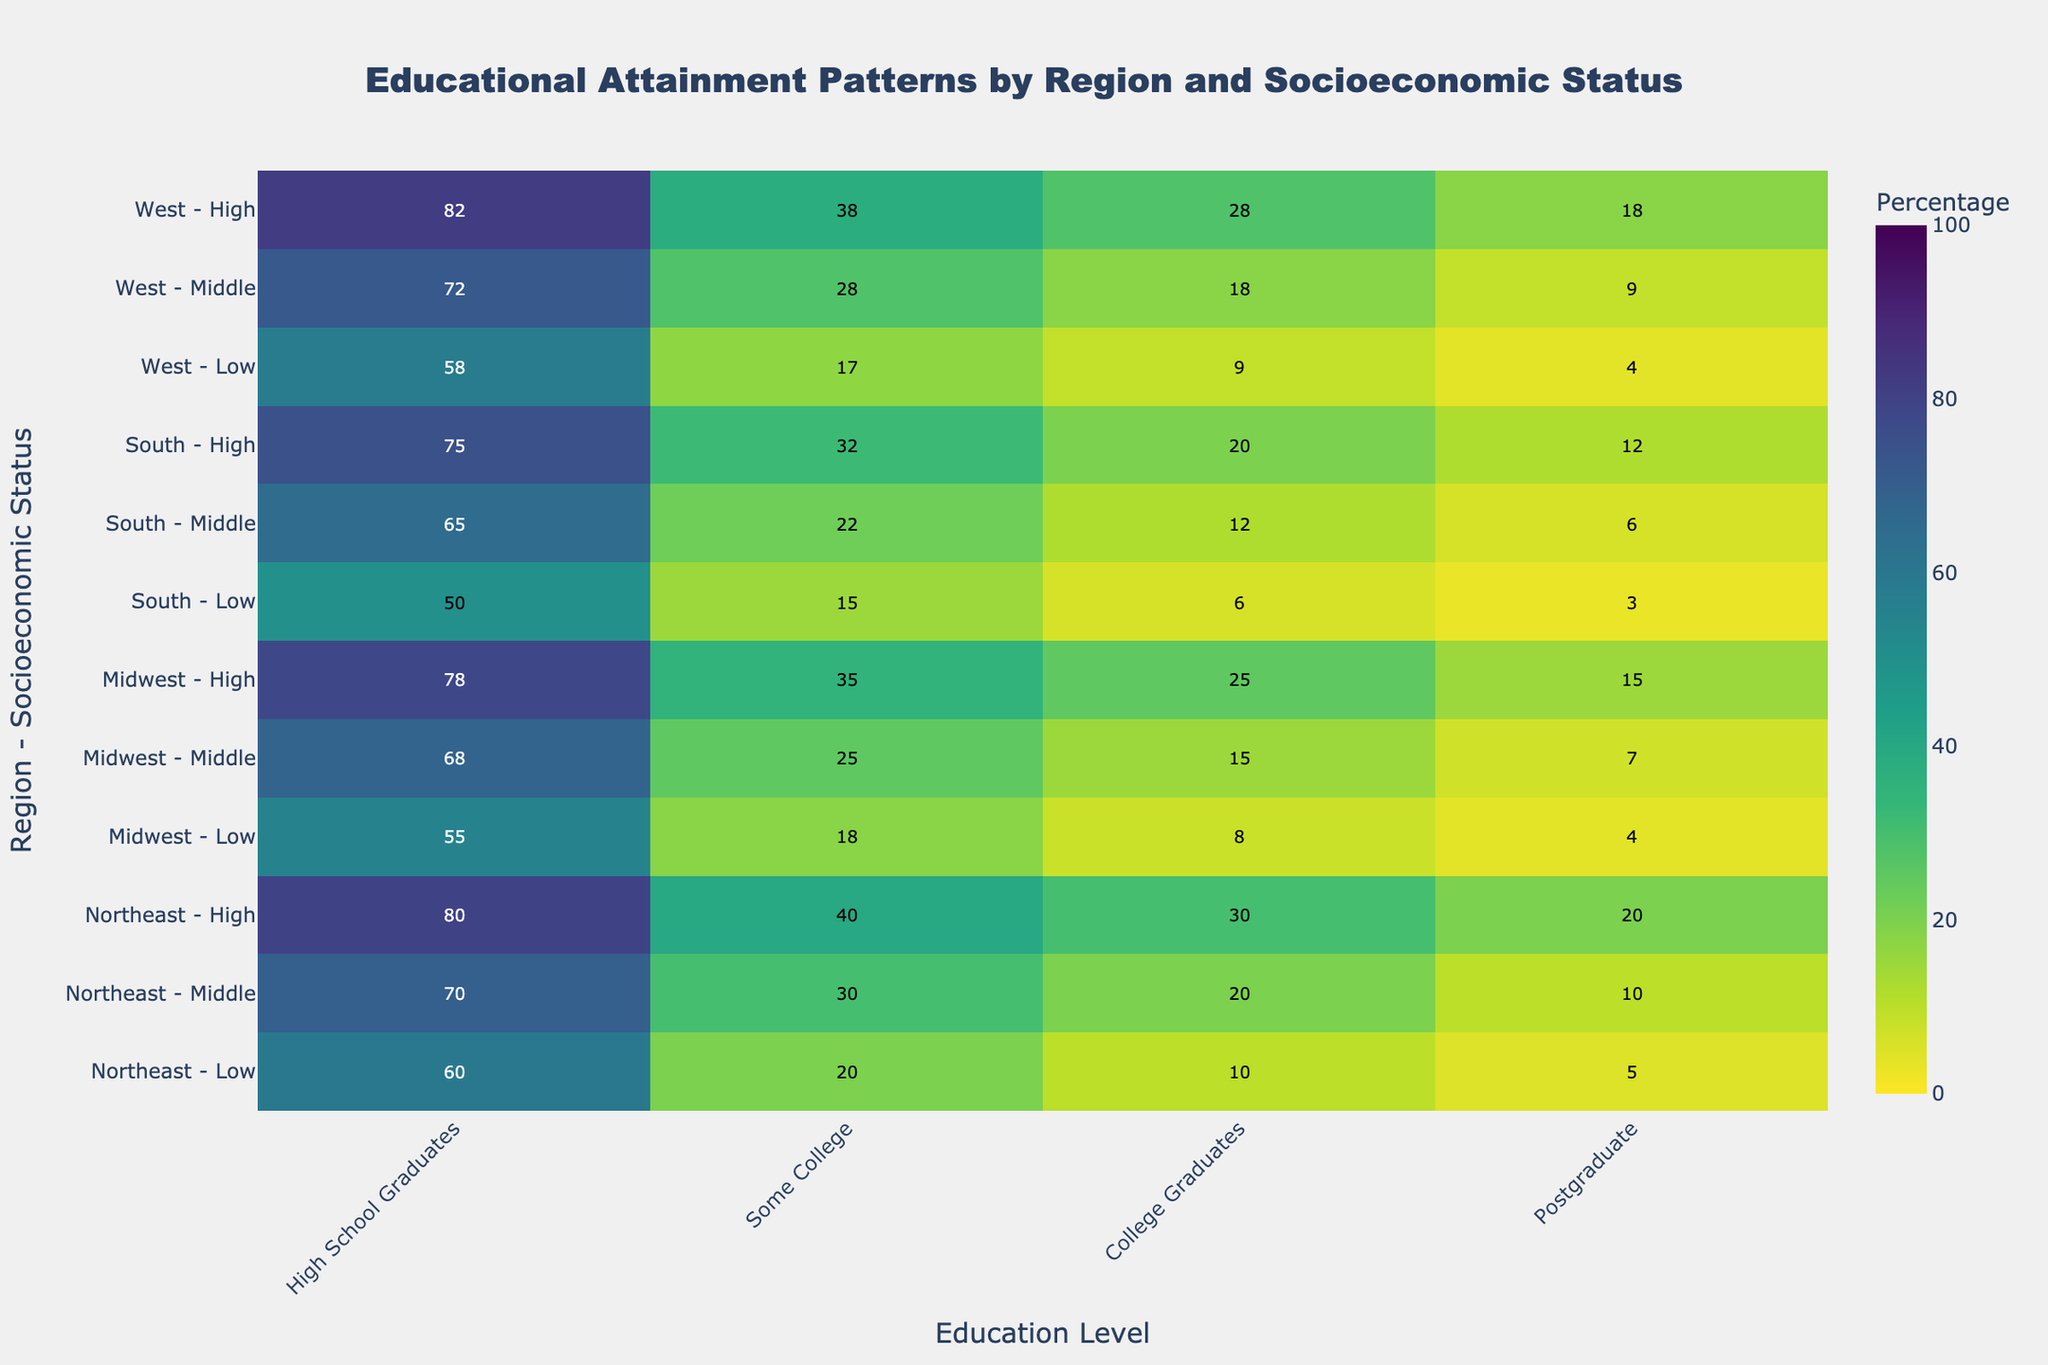What is the highest percentage of high school graduates among the regions and socioeconomic statuses? In the heatmap, look for the highest number in the 'High School Graduates' column. This number is 82, found in the row for the "West - High" category.
Answer: 82 Which region and socioeconomic status combination has the lowest percentage of college graduates? In the 'College Graduates' column, the heatmap shows that the lowest percentage is 6, seen in the row for the "South - Low" category.
Answer: South - Low What is the sum of postgraduate percentages for the Northeast region? Look at the 'Postgraduate' column for all rows that start with "Northeast." The values are 5, 10, and 20. Summing these values gives 5 + 10 + 20 = 35.
Answer: 35 Compare the percentage of people with some college education between the Midwest and the South for the middle socioeconomic status. Which is higher? For middle socioeconomic status, the 'Some College' percentages are 25 for the Midwest and 22 for the South. 25 is higher than 22.
Answer: Midwest How many regional and socioeconomic status combinations have at least 70% high school graduates? In the 'High School Graduates' column, count rows with values of 70 or higher. The corresponding values are: 70 (Northeast - Middle), 80 (Northeast - High), 78 (Midwest - High), 75 (South - High), 72 (West - Middle), and 82 (West - High). This yields 6 combinations.
Answer: 6 In which region and socioeconomic status combination is the percentage difference between high school graduates and college graduates the smallest? Calculate the difference between percentages in the 'High School Graduates' and 'College Graduates' columns for each row, then identify the smallest difference. The smallest difference is 50 for "South - Low", with values 50 (High School) and 0 (College).
Answer: South - Low What is the average percentage of people with some college education in the West region across all socioeconomic statuses? In the 'Some College' column, collect values for all rows starting with "West." The values are 17, 28, and 38. Summing these gives 17 + 28 + 38 = 83, and the average is 83 / 3 ≈ 27.67.
Answer: 27.67 How does the percentage of college graduates in the Midwest - High category compare to that in the Northeast - Middle category? In the 'College Graduates' column, the percentages are 25 for "Midwest - High" and 20 for "Northeast - Middle." 25 is greater than 20.
Answer: Greater Which region and socioeconomic status combination has the highest percentage of people with postgraduate education? Look for the highest number in the 'Postgraduate' column. The highest percentage is 20, seen in the row for "Northeast - High."
Answer: Northeast - High 